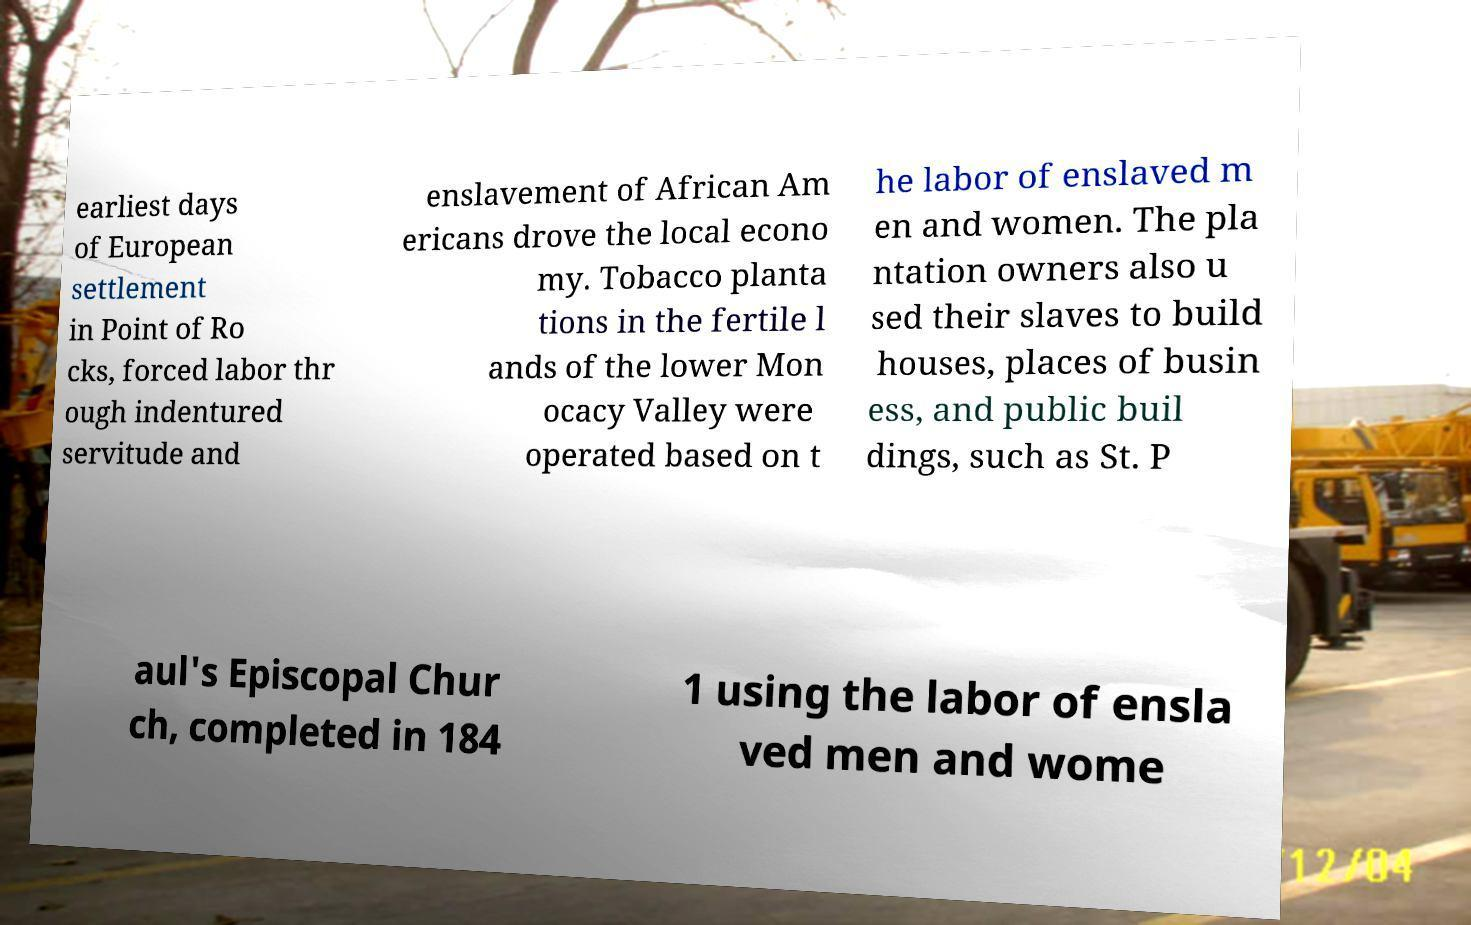There's text embedded in this image that I need extracted. Can you transcribe it verbatim? earliest days of European settlement in Point of Ro cks, forced labor thr ough indentured servitude and enslavement of African Am ericans drove the local econo my. Tobacco planta tions in the fertile l ands of the lower Mon ocacy Valley were operated based on t he labor of enslaved m en and women. The pla ntation owners also u sed their slaves to build houses, places of busin ess, and public buil dings, such as St. P aul's Episcopal Chur ch, completed in 184 1 using the labor of ensla ved men and wome 